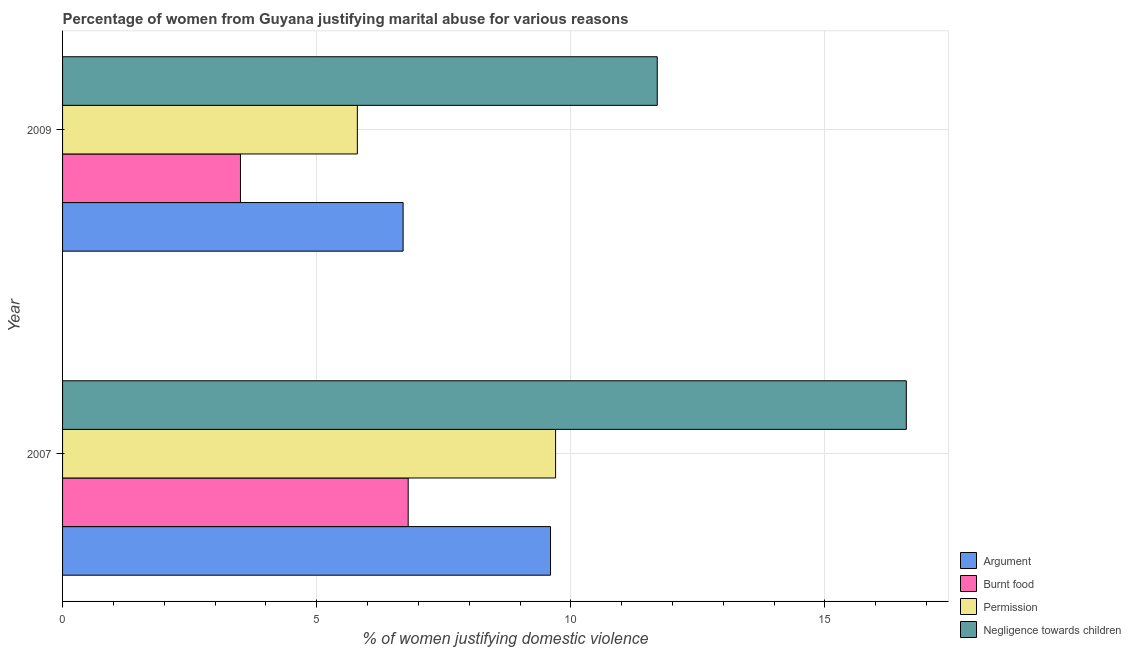How many different coloured bars are there?
Offer a very short reply. 4. Are the number of bars on each tick of the Y-axis equal?
Your response must be concise. Yes. How many bars are there on the 1st tick from the top?
Provide a short and direct response. 4. What is the label of the 2nd group of bars from the top?
Give a very brief answer. 2007. In how many cases, is the number of bars for a given year not equal to the number of legend labels?
Your answer should be very brief. 0. Across all years, what is the maximum percentage of women justifying abuse in the case of an argument?
Provide a short and direct response. 9.6. In which year was the percentage of women justifying abuse for going without permission maximum?
Give a very brief answer. 2007. What is the total percentage of women justifying abuse for showing negligence towards children in the graph?
Keep it short and to the point. 28.3. What is the average percentage of women justifying abuse for going without permission per year?
Ensure brevity in your answer.  7.75. In how many years, is the percentage of women justifying abuse in the case of an argument greater than 9 %?
Your answer should be compact. 1. What is the ratio of the percentage of women justifying abuse for burning food in 2007 to that in 2009?
Provide a succinct answer. 1.94. Is the percentage of women justifying abuse for showing negligence towards children in 2007 less than that in 2009?
Offer a very short reply. No. Is the difference between the percentage of women justifying abuse in the case of an argument in 2007 and 2009 greater than the difference between the percentage of women justifying abuse for going without permission in 2007 and 2009?
Your answer should be very brief. No. Is it the case that in every year, the sum of the percentage of women justifying abuse in the case of an argument and percentage of women justifying abuse for going without permission is greater than the sum of percentage of women justifying abuse for showing negligence towards children and percentage of women justifying abuse for burning food?
Offer a terse response. No. What does the 3rd bar from the top in 2009 represents?
Make the answer very short. Burnt food. What does the 2nd bar from the bottom in 2007 represents?
Provide a short and direct response. Burnt food. Is it the case that in every year, the sum of the percentage of women justifying abuse in the case of an argument and percentage of women justifying abuse for burning food is greater than the percentage of women justifying abuse for going without permission?
Ensure brevity in your answer.  Yes. How many bars are there?
Your answer should be compact. 8. What is the difference between two consecutive major ticks on the X-axis?
Give a very brief answer. 5. Are the values on the major ticks of X-axis written in scientific E-notation?
Your answer should be compact. No. Does the graph contain any zero values?
Provide a succinct answer. No. Does the graph contain grids?
Your response must be concise. Yes. What is the title of the graph?
Make the answer very short. Percentage of women from Guyana justifying marital abuse for various reasons. What is the label or title of the X-axis?
Provide a succinct answer. % of women justifying domestic violence. What is the label or title of the Y-axis?
Ensure brevity in your answer.  Year. What is the % of women justifying domestic violence of Argument in 2007?
Ensure brevity in your answer.  9.6. What is the % of women justifying domestic violence in Burnt food in 2007?
Make the answer very short. 6.8. What is the % of women justifying domestic violence of Permission in 2007?
Your answer should be compact. 9.7. What is the % of women justifying domestic violence in Argument in 2009?
Your response must be concise. 6.7. What is the % of women justifying domestic violence in Burnt food in 2009?
Give a very brief answer. 3.5. What is the % of women justifying domestic violence in Negligence towards children in 2009?
Your response must be concise. 11.7. Across all years, what is the maximum % of women justifying domestic violence in Permission?
Provide a succinct answer. 9.7. Across all years, what is the maximum % of women justifying domestic violence of Negligence towards children?
Offer a very short reply. 16.6. Across all years, what is the minimum % of women justifying domestic violence in Argument?
Your response must be concise. 6.7. Across all years, what is the minimum % of women justifying domestic violence in Permission?
Ensure brevity in your answer.  5.8. Across all years, what is the minimum % of women justifying domestic violence in Negligence towards children?
Give a very brief answer. 11.7. What is the total % of women justifying domestic violence of Argument in the graph?
Offer a very short reply. 16.3. What is the total % of women justifying domestic violence of Burnt food in the graph?
Your answer should be very brief. 10.3. What is the total % of women justifying domestic violence in Permission in the graph?
Offer a very short reply. 15.5. What is the total % of women justifying domestic violence in Negligence towards children in the graph?
Your answer should be very brief. 28.3. What is the difference between the % of women justifying domestic violence in Burnt food in 2007 and that in 2009?
Offer a terse response. 3.3. What is the difference between the % of women justifying domestic violence of Permission in 2007 and that in 2009?
Your answer should be very brief. 3.9. What is the difference between the % of women justifying domestic violence in Argument in 2007 and the % of women justifying domestic violence in Burnt food in 2009?
Your answer should be very brief. 6.1. What is the difference between the % of women justifying domestic violence in Argument in 2007 and the % of women justifying domestic violence in Permission in 2009?
Make the answer very short. 3.8. What is the difference between the % of women justifying domestic violence in Argument in 2007 and the % of women justifying domestic violence in Negligence towards children in 2009?
Provide a short and direct response. -2.1. What is the difference between the % of women justifying domestic violence of Burnt food in 2007 and the % of women justifying domestic violence of Negligence towards children in 2009?
Provide a succinct answer. -4.9. What is the average % of women justifying domestic violence in Argument per year?
Provide a succinct answer. 8.15. What is the average % of women justifying domestic violence in Burnt food per year?
Give a very brief answer. 5.15. What is the average % of women justifying domestic violence in Permission per year?
Keep it short and to the point. 7.75. What is the average % of women justifying domestic violence in Negligence towards children per year?
Ensure brevity in your answer.  14.15. In the year 2007, what is the difference between the % of women justifying domestic violence of Argument and % of women justifying domestic violence of Permission?
Provide a succinct answer. -0.1. In the year 2007, what is the difference between the % of women justifying domestic violence in Permission and % of women justifying domestic violence in Negligence towards children?
Your response must be concise. -6.9. In the year 2009, what is the difference between the % of women justifying domestic violence in Argument and % of women justifying domestic violence in Burnt food?
Your answer should be compact. 3.2. In the year 2009, what is the difference between the % of women justifying domestic violence of Argument and % of women justifying domestic violence of Negligence towards children?
Provide a succinct answer. -5. In the year 2009, what is the difference between the % of women justifying domestic violence of Permission and % of women justifying domestic violence of Negligence towards children?
Offer a terse response. -5.9. What is the ratio of the % of women justifying domestic violence in Argument in 2007 to that in 2009?
Offer a terse response. 1.43. What is the ratio of the % of women justifying domestic violence in Burnt food in 2007 to that in 2009?
Your answer should be compact. 1.94. What is the ratio of the % of women justifying domestic violence in Permission in 2007 to that in 2009?
Provide a short and direct response. 1.67. What is the ratio of the % of women justifying domestic violence of Negligence towards children in 2007 to that in 2009?
Offer a terse response. 1.42. What is the difference between the highest and the second highest % of women justifying domestic violence of Burnt food?
Your answer should be compact. 3.3. What is the difference between the highest and the second highest % of women justifying domestic violence in Negligence towards children?
Make the answer very short. 4.9. What is the difference between the highest and the lowest % of women justifying domestic violence of Argument?
Make the answer very short. 2.9. What is the difference between the highest and the lowest % of women justifying domestic violence of Permission?
Provide a short and direct response. 3.9. 